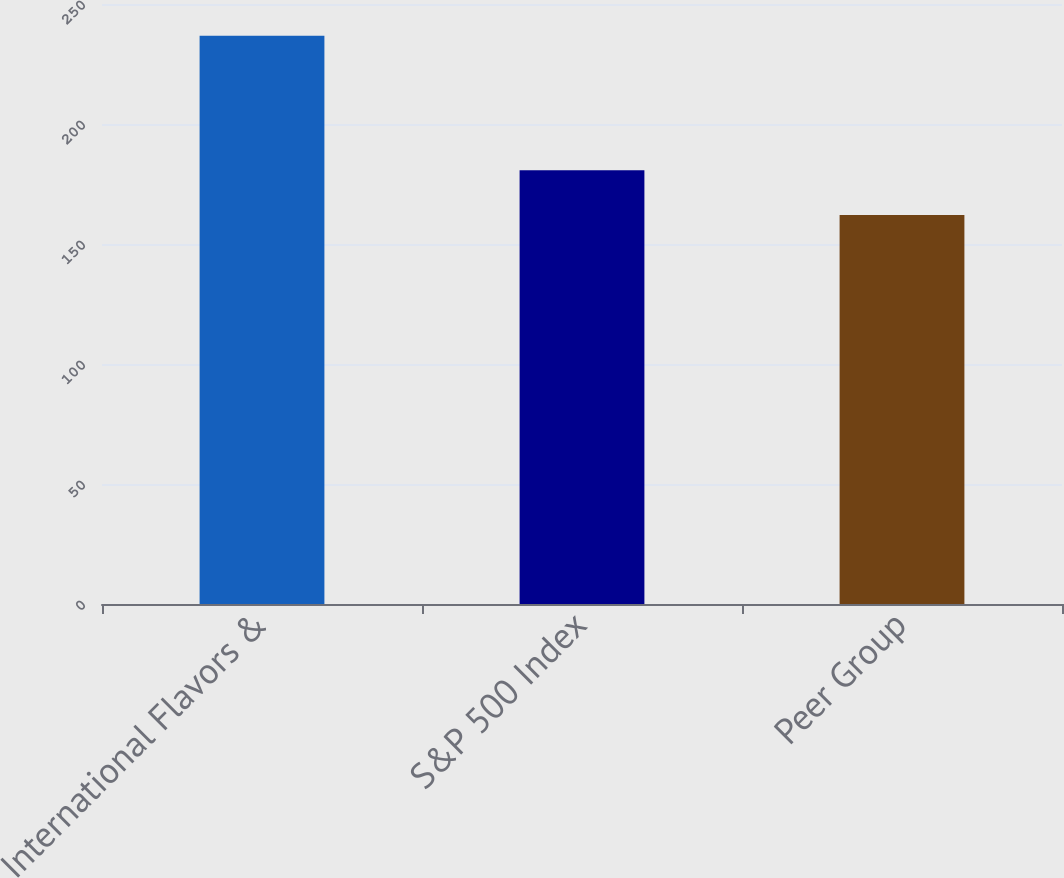Convert chart to OTSL. <chart><loc_0><loc_0><loc_500><loc_500><bar_chart><fcel>International Flavors &<fcel>S&P 500 Index<fcel>Peer Group<nl><fcel>236.78<fcel>180.75<fcel>162.09<nl></chart> 